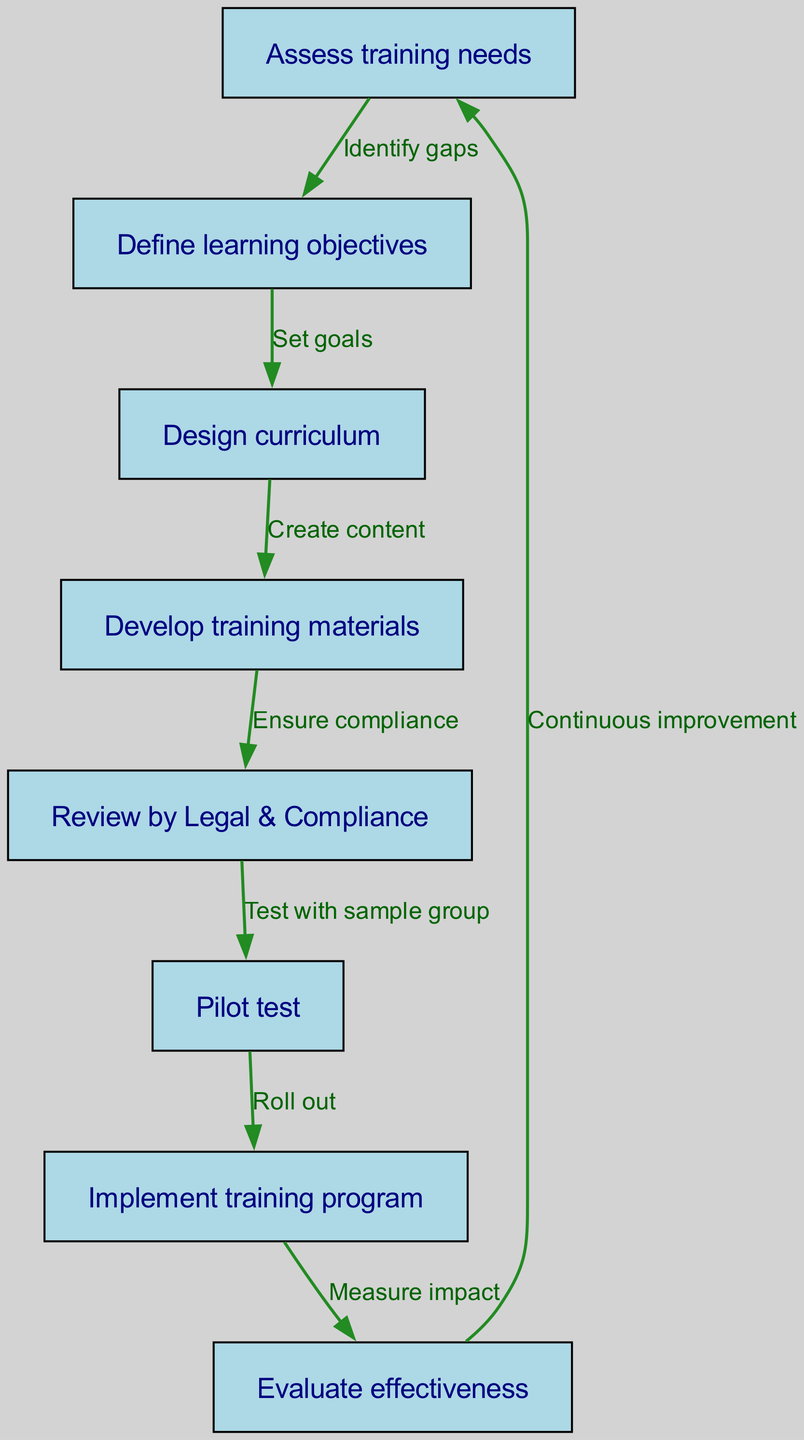What is the first step in the compliance training program development? The first step is clearly marked at the top of the flowchart, which indicates that the development process begins with assessing training needs.
Answer: Assess training needs How many nodes are there in the diagram? By counting the labeled boxes in the diagram, we can see that there are eight distinct steps or nodes in the process.
Answer: Eight What is the relationship between "Define learning objectives" and "Design curriculum"? The flowchart illustrates that "Define learning objectives" is followed by "Design curriculum", indicating that setting goals directly leads to curriculum design.
Answer: Set goals Which step follows "Pilot test"? Following the "Pilot test", the next step indicated in the flowchart is "Implement training program", showing the sequential process after testing.
Answer: Implement training program What does "Evaluate effectiveness" lead to? According to the diagram, "Evaluate effectiveness" leads back to "Assess training needs", highlighting a continuous improvement cycle in the compliance training program.
Answer: Continuous improvement What is ensured during the step "Develop training materials"? The flowchart shows that during the "Develop training materials" phase, the focus is on ensuring compliance, suggesting that materials must meet legal and compliance standards.
Answer: Ensure compliance What is the purpose of the "Review by Legal & Compliance" step? The purpose of the "Review by Legal & Compliance" step is to ensure that the training materials meet all regulatory standards before proceeding to pilot testing.
Answer: Ensure compliance Which node has the most directed edges pointing towards it? By analyzing the relationships in the flowchart, we see that "Evaluate effectiveness" has one edge coming in from "Implement training program", marking it as the node primarily accumulating inputs in the process.
Answer: One 